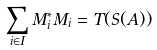<formula> <loc_0><loc_0><loc_500><loc_500>\sum _ { i \in I } M _ { i } ^ { * } M _ { i } = T ( S ( A ) )</formula> 